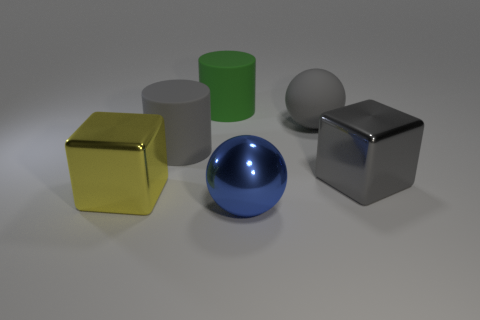Add 1 brown matte things. How many objects exist? 7 Subtract all cubes. How many objects are left? 4 Subtract 0 brown cylinders. How many objects are left? 6 Subtract all large shiny things. Subtract all purple blocks. How many objects are left? 3 Add 2 large gray cylinders. How many large gray cylinders are left? 3 Add 6 big rubber cylinders. How many big rubber cylinders exist? 8 